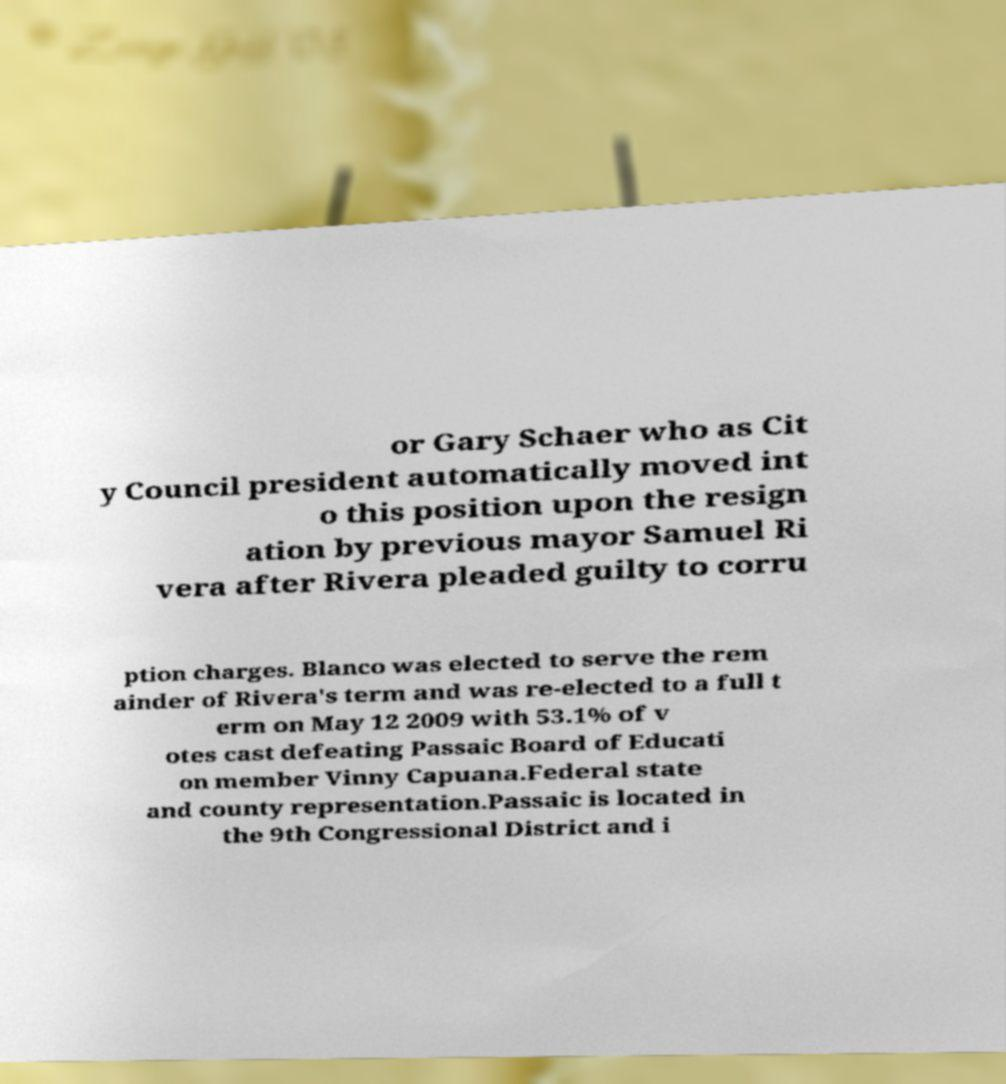I need the written content from this picture converted into text. Can you do that? or Gary Schaer who as Cit y Council president automatically moved int o this position upon the resign ation by previous mayor Samuel Ri vera after Rivera pleaded guilty to corru ption charges. Blanco was elected to serve the rem ainder of Rivera's term and was re-elected to a full t erm on May 12 2009 with 53.1% of v otes cast defeating Passaic Board of Educati on member Vinny Capuana.Federal state and county representation.Passaic is located in the 9th Congressional District and i 